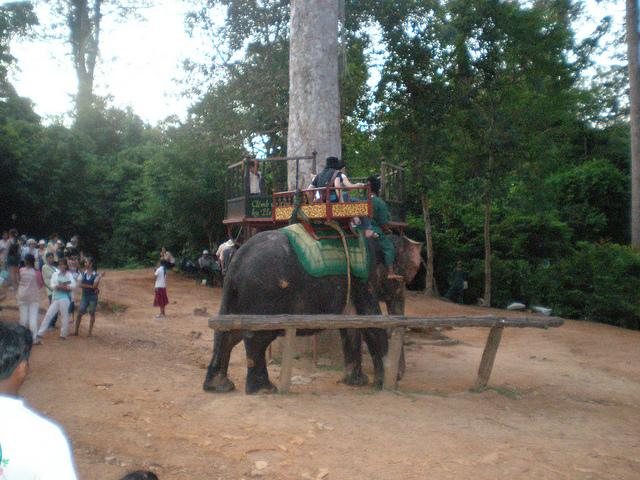What continent is this most likely? asia 